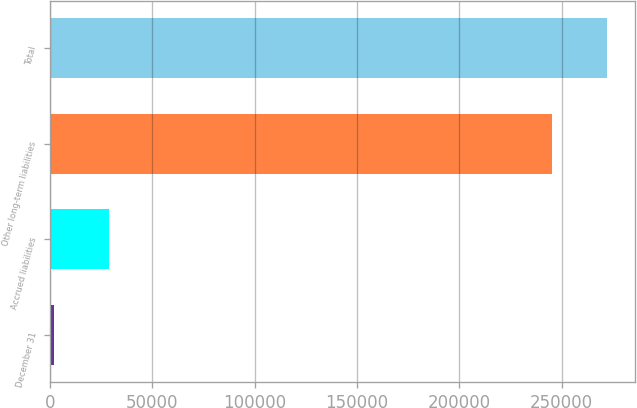<chart> <loc_0><loc_0><loc_500><loc_500><bar_chart><fcel>December 31<fcel>Accrued liabilities<fcel>Other long-term liabilities<fcel>Total<nl><fcel>2013<fcel>28905.4<fcel>245460<fcel>272352<nl></chart> 